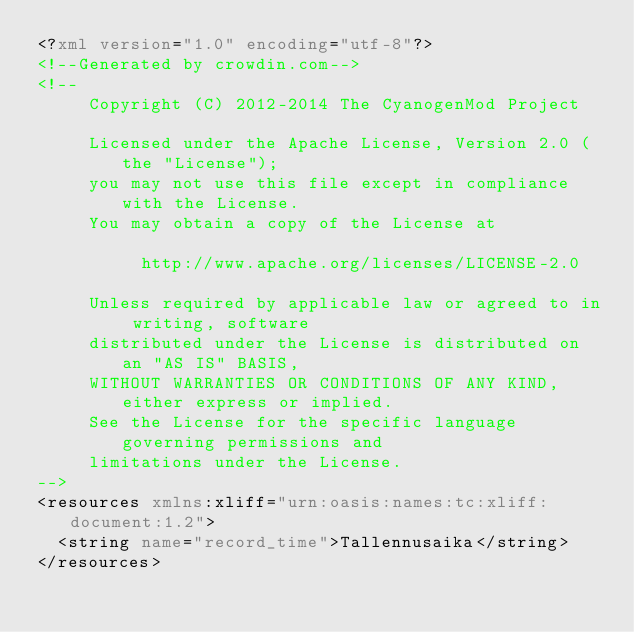<code> <loc_0><loc_0><loc_500><loc_500><_XML_><?xml version="1.0" encoding="utf-8"?>
<!--Generated by crowdin.com-->
<!--
     Copyright (C) 2012-2014 The CyanogenMod Project

     Licensed under the Apache License, Version 2.0 (the "License");
     you may not use this file except in compliance with the License.
     You may obtain a copy of the License at

          http://www.apache.org/licenses/LICENSE-2.0

     Unless required by applicable law or agreed to in writing, software
     distributed under the License is distributed on an "AS IS" BASIS,
     WITHOUT WARRANTIES OR CONDITIONS OF ANY KIND, either express or implied.
     See the License for the specific language governing permissions and
     limitations under the License.
-->
<resources xmlns:xliff="urn:oasis:names:tc:xliff:document:1.2">
  <string name="record_time">Tallennusaika</string>
</resources>
</code> 